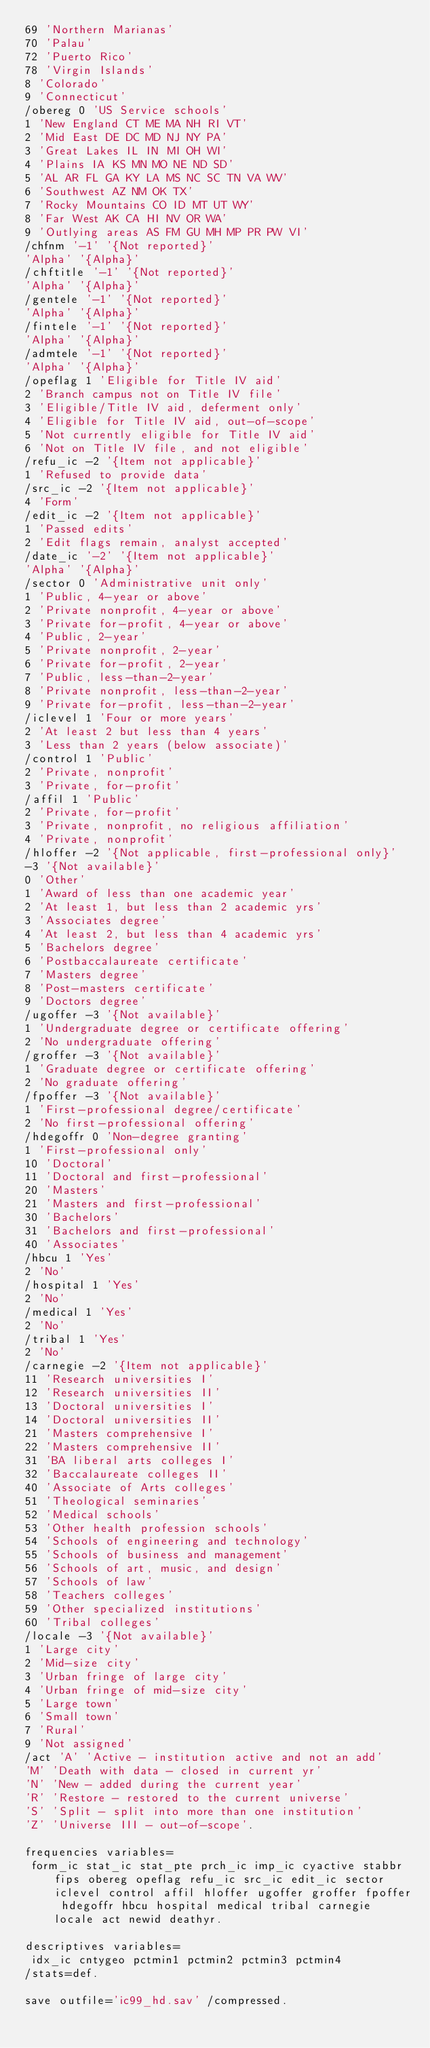Convert code to text. <code><loc_0><loc_0><loc_500><loc_500><_Scheme_>69 'Northern Marianas'
70 'Palau'
72 'Puerto Rico'
78 'Virgin Islands'
8 'Colorado'
9 'Connecticut'
/obereg 0 'US Service schools'
1 'New England CT ME MA NH RI VT'
2 'Mid East DE DC MD NJ NY PA'
3 'Great Lakes IL IN MI OH WI'
4 'Plains IA KS MN MO NE ND SD'
5 'AL AR FL GA KY LA MS NC SC TN VA WV'
6 'Southwest AZ NM OK TX'
7 'Rocky Mountains CO ID MT UT WY'
8 'Far West AK CA HI NV OR WA'
9 'Outlying areas AS FM GU MH MP PR PW VI'
/chfnm '-1' '{Not reported}'
'Alpha' '{Alpha}'
/chftitle '-1' '{Not reported}'
'Alpha' '{Alpha}'
/gentele '-1' '{Not reported}'
'Alpha' '{Alpha}'
/fintele '-1' '{Not reported}'
'Alpha' '{Alpha}'
/admtele '-1' '{Not reported}'
'Alpha' '{Alpha}'
/opeflag 1 'Eligible for Title IV aid'
2 'Branch campus not on Title IV file'
3 'Eligible/Title IV aid, deferment only'
4 'Eligible for Title IV aid, out-of-scope'
5 'Not currently eligible for Title IV aid'
6 'Not on Title IV file, and not eligible'
/refu_ic -2 '{Item not applicable}'
1 'Refused to provide data'
/src_ic -2 '{Item not applicable}'
4 'Form'
/edit_ic -2 '{Item not applicable}'
1 'Passed edits'
2 'Edit flags remain, analyst accepted'
/date_ic '-2' '{Item not applicable}'
'Alpha' '{Alpha}'
/sector 0 'Administrative unit only'
1 'Public, 4-year or above'
2 'Private nonprofit, 4-year or above'
3 'Private for-profit, 4-year or above'
4 'Public, 2-year'
5 'Private nonprofit, 2-year'
6 'Private for-profit, 2-year'
7 'Public, less-than-2-year'
8 'Private nonprofit, less-than-2-year'
9 'Private for-profit, less-than-2-year'
/iclevel 1 'Four or more years'
2 'At least 2 but less than 4 years'
3 'Less than 2 years (below associate)'
/control 1 'Public'
2 'Private, nonprofit'
3 'Private, for-profit'
/affil 1 'Public'
2 'Private, for-profit'
3 'Private, nonprofit, no religious affiliation'
4 'Private, nonprofit'
/hloffer -2 '{Not applicable, first-professional only}'
-3 '{Not available}'
0 'Other'
1 'Award of less than one academic year'
2 'At least 1, but less than 2 academic yrs'
3 'Associates degree'
4 'At least 2, but less than 4 academic yrs'
5 'Bachelors degree'
6 'Postbaccalaureate certificate'
7 'Masters degree'
8 'Post-masters certificate'
9 'Doctors degree'
/ugoffer -3 '{Not available}'
1 'Undergraduate degree or certificate offering'
2 'No undergraduate offering'
/groffer -3 '{Not available}'
1 'Graduate degree or certificate offering'
2 'No graduate offering'
/fpoffer -3 '{Not available}'
1 'First-professional degree/certificate'
2 'No first-professional offering'
/hdegoffr 0 'Non-degree granting'
1 'First-professional only'
10 'Doctoral'
11 'Doctoral and first-professional'
20 'Masters'
21 'Masters and first-professional'
30 'Bachelors'
31 'Bachelors and first-professional'
40 'Associates'
/hbcu 1 'Yes'
2 'No'
/hospital 1 'Yes'
2 'No'
/medical 1 'Yes'
2 'No'
/tribal 1 'Yes'
2 'No'
/carnegie -2 '{Item not applicable}'
11 'Research universities I'
12 'Research universities II'
13 'Doctoral universities I'
14 'Doctoral universities II'
21 'Masters comprehensive I'
22 'Masters comprehensive II'
31 'BA liberal arts colleges I'
32 'Baccalaureate colleges II'
40 'Associate of Arts colleges'
51 'Theological seminaries'
52 'Medical schools'
53 'Other health profession schools'
54 'Schools of engineering and technology'
55 'Schools of business and management'
56 'Schools of art, music, and design'
57 'Schools of law'
58 'Teachers colleges'
59 'Other specialized institutions'
60 'Tribal colleges'
/locale -3 '{Not available}'
1 'Large city'
2 'Mid-size city'
3 'Urban fringe of large city'
4 'Urban fringe of mid-size city'
5 'Large town'
6 'Small town'
7 'Rural'
9 'Not assigned'
/act 'A' 'Active - institution active and not an add'
'M' 'Death with data - closed in current yr'
'N' 'New - added during the current year'
'R' 'Restore - restored to the current universe'
'S' 'Split - split into more than one institution'
'Z' 'Universe III - out-of-scope'.

frequencies variables=
 form_ic stat_ic stat_pte prch_ic imp_ic cyactive stabbr fips obereg opeflag refu_ic src_ic edit_ic sector iclevel control affil hloffer ugoffer groffer fpoffer hdegoffr hbcu hospital medical tribal carnegie locale act newid deathyr.

descriptives variables=
 idx_ic cntygeo pctmin1 pctmin2 pctmin3 pctmin4
/stats=def.

save outfile='ic99_hd.sav' /compressed.

</code> 